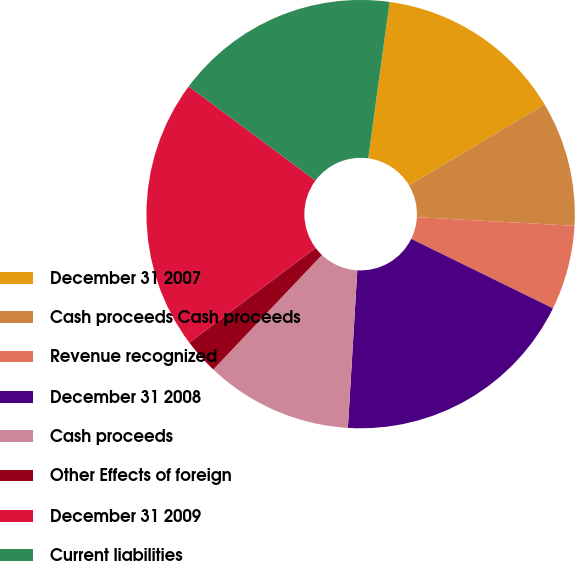Convert chart to OTSL. <chart><loc_0><loc_0><loc_500><loc_500><pie_chart><fcel>December 31 2007<fcel>Cash proceeds Cash proceeds<fcel>Revenue recognized<fcel>December 31 2008<fcel>Cash proceeds<fcel>Other Effects of foreign<fcel>December 31 2009<fcel>Current liabilities<nl><fcel>14.29%<fcel>9.42%<fcel>6.38%<fcel>18.7%<fcel>11.13%<fcel>2.68%<fcel>20.41%<fcel>16.99%<nl></chart> 